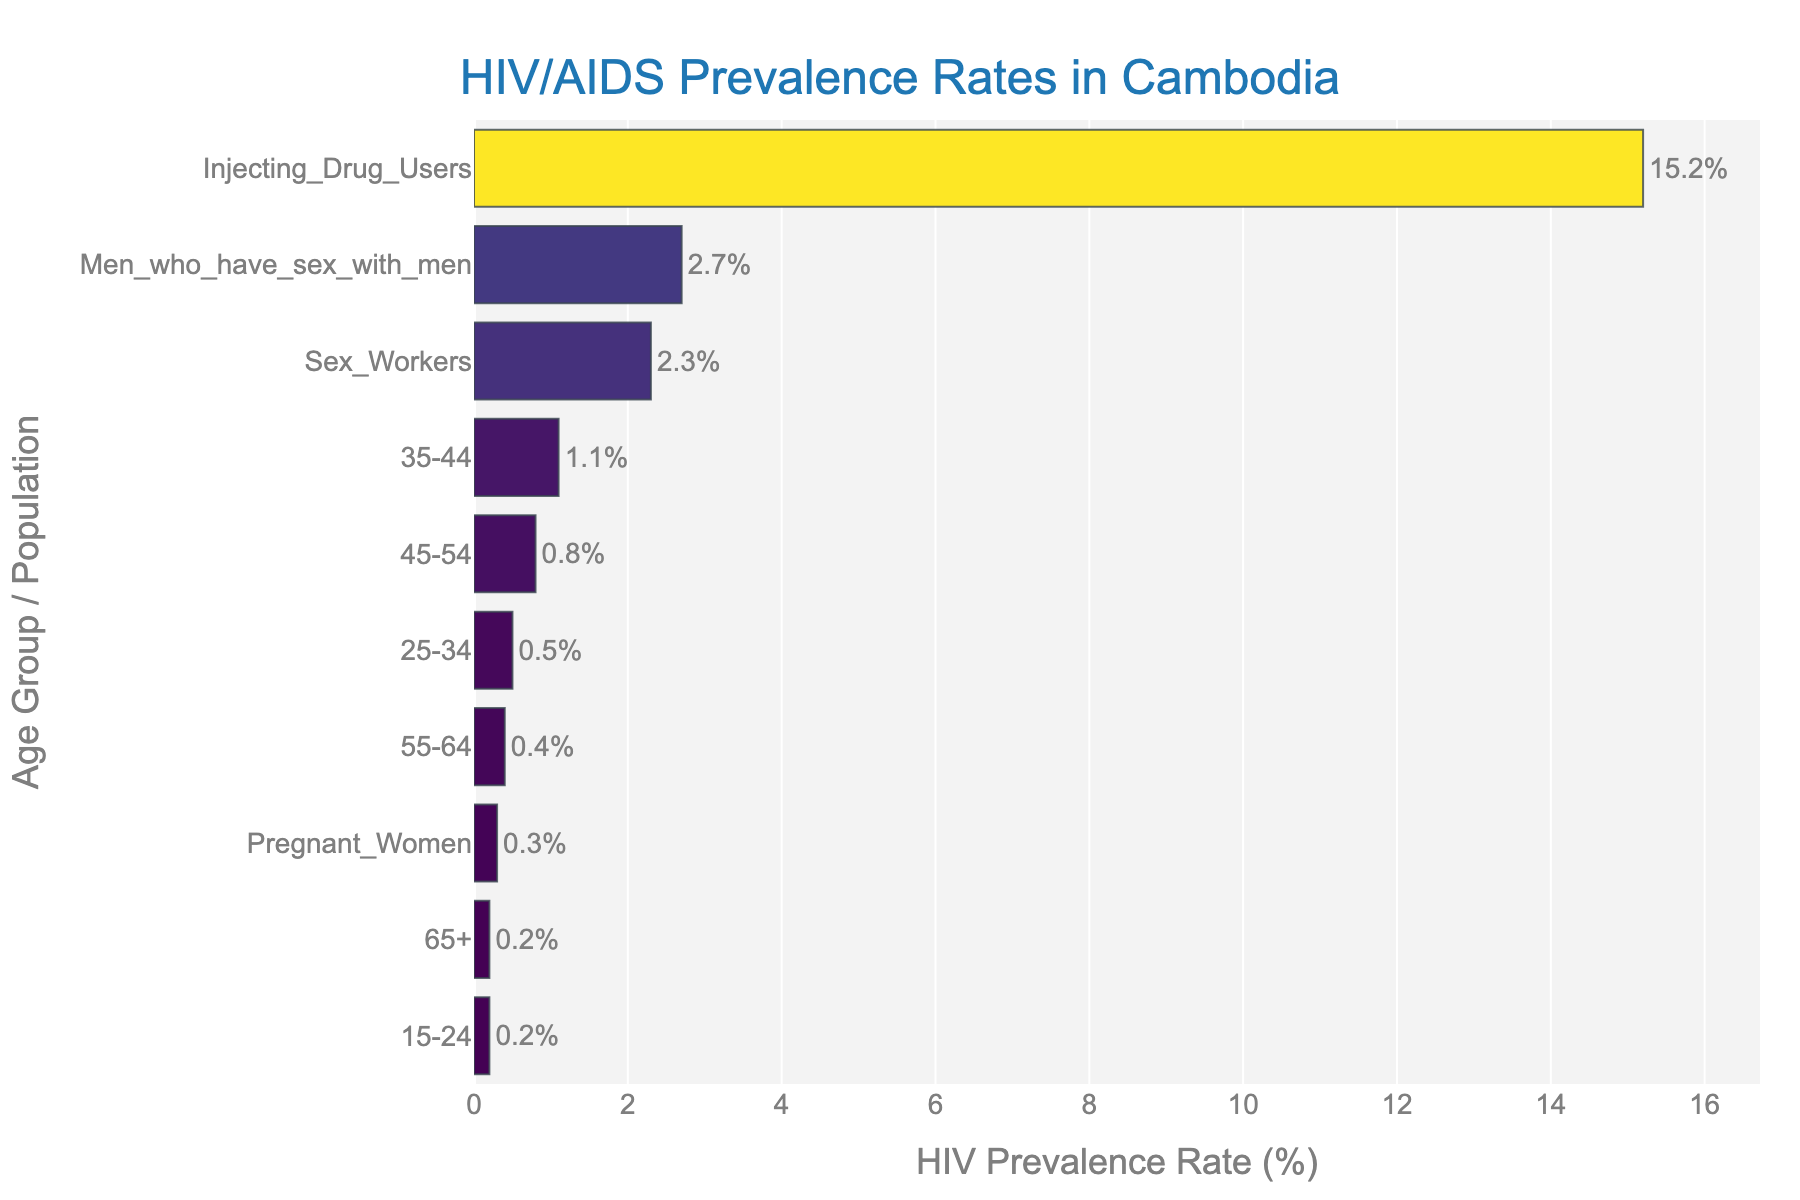what is the title of the figure? The title of the figure is located at the top center and is written in a larger font compared to other texts. It also has a specific color to make it stand out.
Answer: HIV/AIDS Prevalence Rates in Cambodia Which age group has the highest HIV prevalence rate? To find the age group with the highest HIV prevalence rate, we need to look at the y-axis for age groups and find the bar that extends the furthest to the right on the x-axis.
Answer: Men who have sex with men What's the HIV prevalence rate for pregnant women? Locate the 'Pregnant Women' category on the y-axis and trace the corresponding bar to the x-axis value.
Answer: 0.3% How does the HIV prevalence rate among injecting drug users compare to sex workers? Find the length of the bars for 'Injecting Drug Users' and 'Sex Workers.' The bar for injecting drug users should extend further.
Answer: Injecting Drug Users have a higher prevalence rate What is the average HIV prevalence rate of all age groups including special populations? Add up the HIV prevalence rates for all groups and divide by the total number of groups. (0.2 + 0.5 + 1.1 + 0.8 + 0.4 + 0.2 + 0.3 + 2.3 + 2.7 + 15.2) / 10 = 23.7 / 10 = 2.37
Answer: 2.37% Which age group has an HIV prevalence rate less than 0.5%? Compare the bars' lengths to find those below the 0.5% x-axis mark.
Answer: 15-24, 55-64, 65+ What is the difference in the HIV prevalence rate between the 35-44 and 45-54 age groups? Subtract the HIV prevalence rate of the 45-54 age group from that of the 35-44 age group. 1.1% - 0.8% = 0.3%
Answer: 0.3% Which groups have an HIV prevalence rate above 1%? Compare the bars' lengths to identify those extending past the 1% mark on the x-axis.
Answer: 35-44, Sex Workers, Men who have sex with men, Injecting Drug Users What's the median HIV prevalence rate of all the groups presented? To determine the median, first list all the rates in numerical order (0.2, 0.2, 0.3, 0.4, 0.5, 0.8, 1.1, 2.3, 2.7, 15.2). The middle values are 0.5 and 0.8, so the median is the average of these two (0.5 + 0.8) / 2 = 0.65%
Answer: 0.65% What is the combined HIV prevalence rate for 25-34 and 35-44 age groups? Add the HIV prevalence rates for both age groups: 0.5% + 1.1% = 1.6%
Answer: 1.6% 